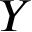Convert formula to latex. <formula><loc_0><loc_0><loc_500><loc_500>Y</formula> 